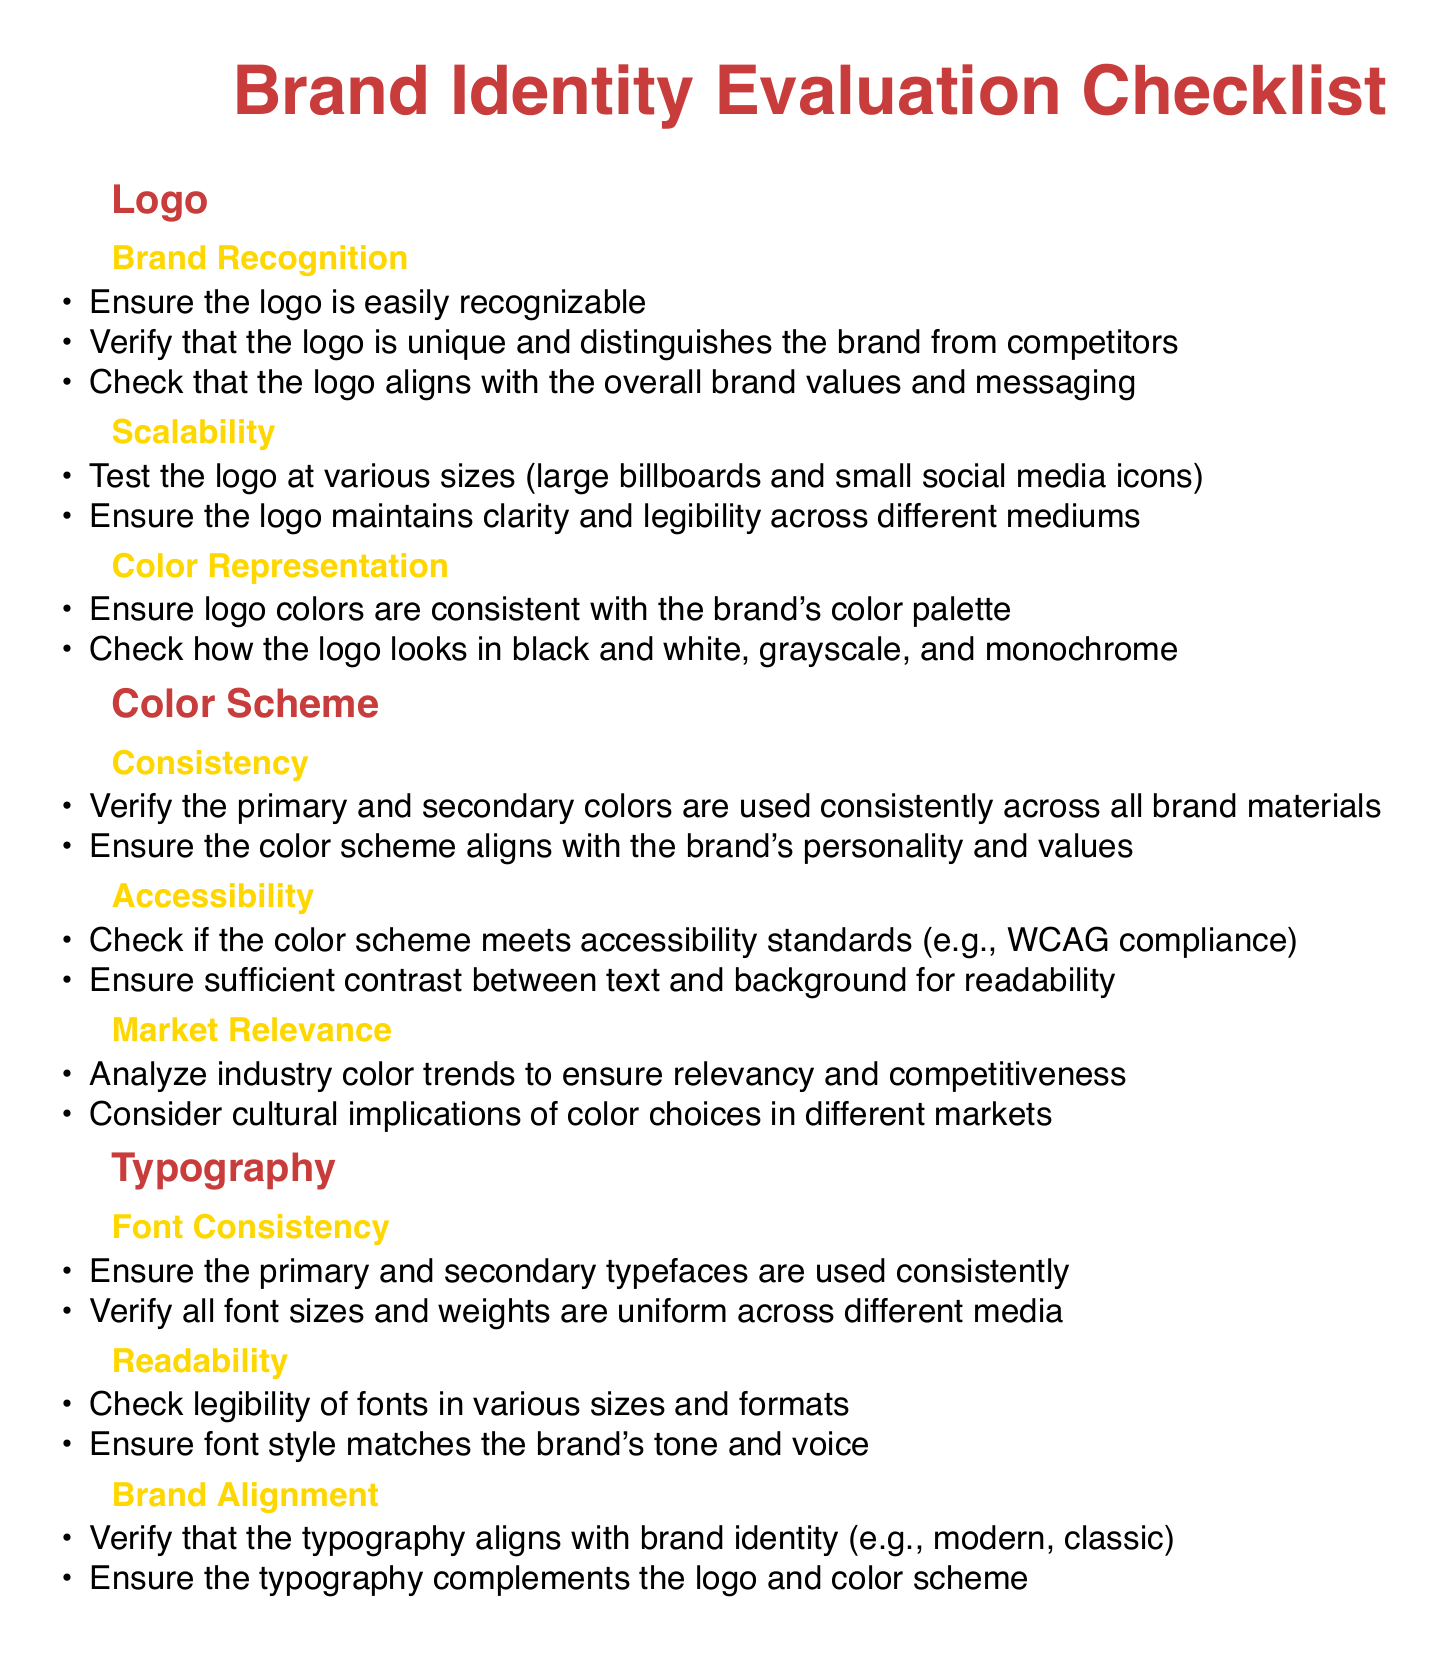What are the primary colors used in the color scheme? The primary colors are listed under the color scheme section, indicating what colors should be consistently used across brand materials.
Answer: Not specified How many sub-sections are under the logo section? The logo section includes multiple sub-sections that detail various aspects of logo evaluation.
Answer: Three What should be tested for the logo's scalability? The scalability of the logo should be tested at various sizes to ensure it maintains clarity.
Answer: Various sizes What accessibility standard should the color scheme meet? The color scheme should meet certain compliance measures, which are essential for inclusivity in design.
Answer: WCAG compliance What is a key consideration in typography for brand alignment? Typography must align with brand identity to convey the correct tone and message.
Answer: Brand identity Which section addresses the analysis of industry color trends? The market relevance section covers the analysis needed to ensure that the brand's color choices are competitive.
Answer: Market Relevance What should be checked regarding the logo colors? The logo colors should be consistent with the overall brand's color palette for cohesive branding.
Answer: Consistent How should the font styles correspond to the brand's tone? Font styles must be appropriate and match the intended tone and voice of the bakery brand.
Answer: Match tone and voice In what format should fonts be checked for readability? Fonts should be checked in various sizes and formats to ensure they are legible across all applications.
Answer: Various sizes and formats 